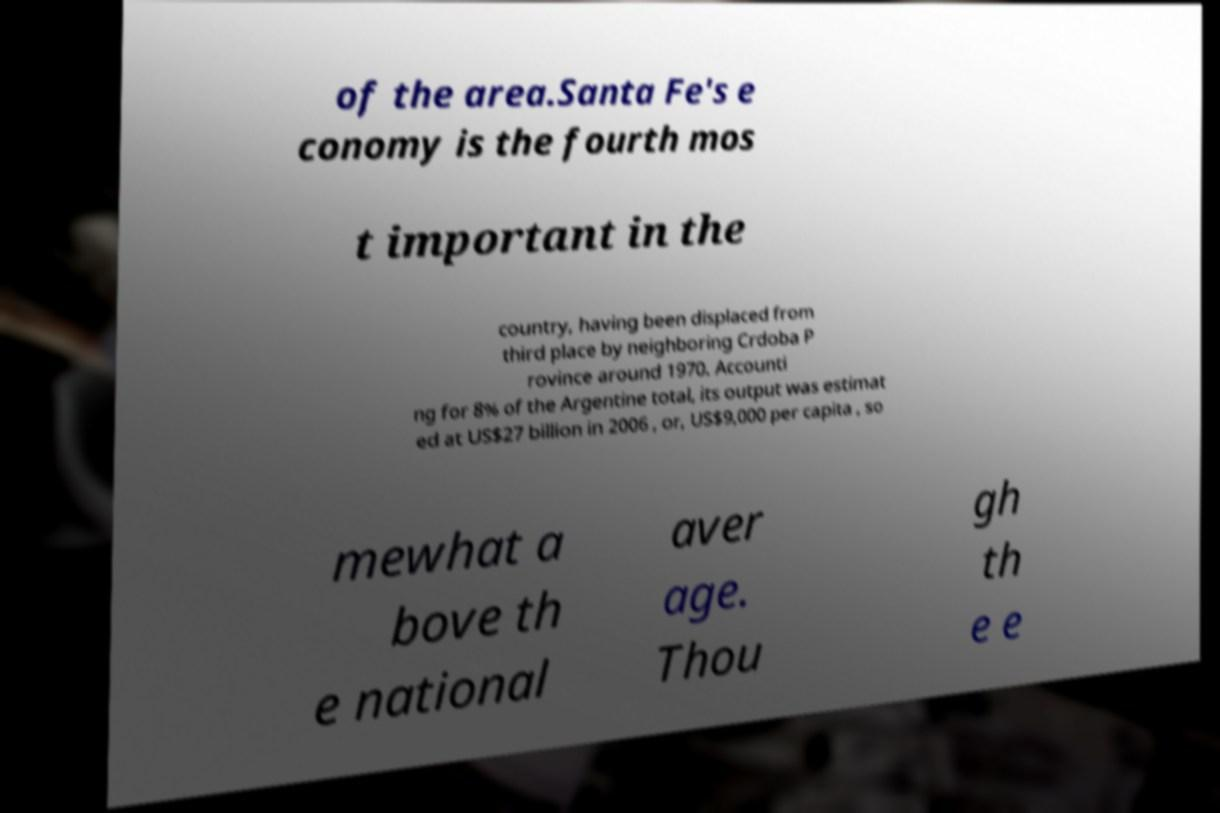What messages or text are displayed in this image? I need them in a readable, typed format. of the area.Santa Fe's e conomy is the fourth mos t important in the country, having been displaced from third place by neighboring Crdoba P rovince around 1970. Accounti ng for 8% of the Argentine total, its output was estimat ed at US$27 billion in 2006 , or, US$9,000 per capita , so mewhat a bove th e national aver age. Thou gh th e e 